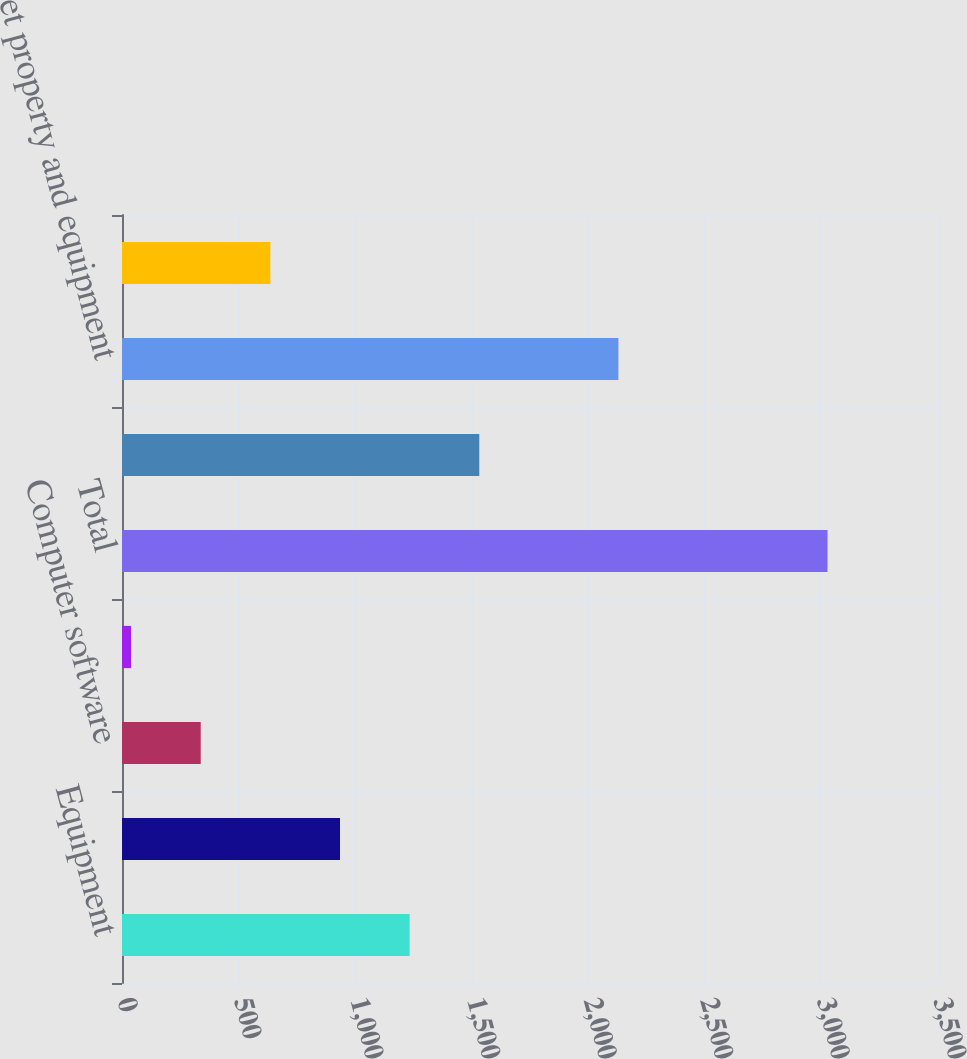Convert chart. <chart><loc_0><loc_0><loc_500><loc_500><bar_chart><fcel>Equipment<fcel>Concession improvements<fcel>Computer software<fcel>Other<fcel>Total<fcel>Accumulated depreciation<fcel>Net property and equipment<fcel>Construction in progress<nl><fcel>1233.78<fcel>935.06<fcel>337.62<fcel>38.9<fcel>3026.1<fcel>1532.5<fcel>2129.1<fcel>636.34<nl></chart> 